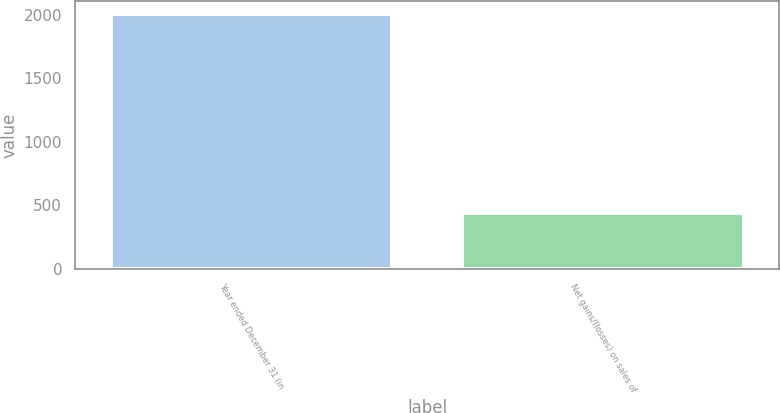Convert chart. <chart><loc_0><loc_0><loc_500><loc_500><bar_chart><fcel>Year ended December 31 (in<fcel>Net gains/(losses) on sales of<nl><fcel>2009<fcel>439<nl></chart> 